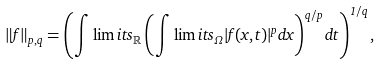<formula> <loc_0><loc_0><loc_500><loc_500>\| f \| _ { p , q } = \left ( \int \lim i t s _ { \mathbb { R } } \left ( \int \lim i t s _ { \Omega } | f ( x , t ) | ^ { p } d x \right ) ^ { q / p } d t \right ) ^ { 1 / q } ,</formula> 